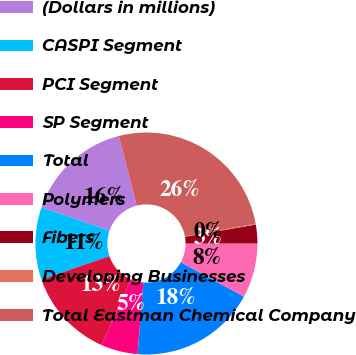Convert chart. <chart><loc_0><loc_0><loc_500><loc_500><pie_chart><fcel>(Dollars in millions)<fcel>CASPI Segment<fcel>PCI Segment<fcel>SP Segment<fcel>Total<fcel>Polymers<fcel>Fibers<fcel>Developing Businesses<fcel>Total Eastman Chemical Company<nl><fcel>15.73%<fcel>10.53%<fcel>13.13%<fcel>5.33%<fcel>18.33%<fcel>7.93%<fcel>2.73%<fcel>0.13%<fcel>26.13%<nl></chart> 